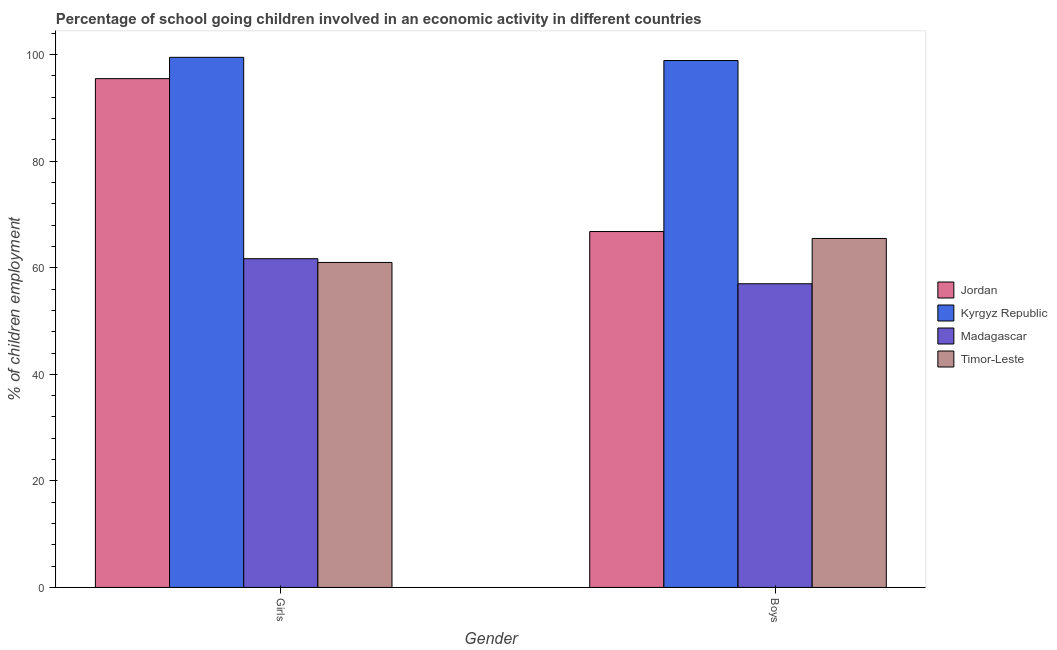What is the label of the 1st group of bars from the left?
Ensure brevity in your answer.  Girls. What is the percentage of school going girls in Timor-Leste?
Your answer should be compact. 61. Across all countries, what is the maximum percentage of school going girls?
Offer a terse response. 99.5. In which country was the percentage of school going girls maximum?
Your answer should be very brief. Kyrgyz Republic. In which country was the percentage of school going girls minimum?
Keep it short and to the point. Timor-Leste. What is the total percentage of school going boys in the graph?
Your answer should be compact. 288.2. What is the difference between the percentage of school going boys in Jordan and that in Kyrgyz Republic?
Give a very brief answer. -32.1. What is the difference between the percentage of school going boys in Madagascar and the percentage of school going girls in Kyrgyz Republic?
Your response must be concise. -42.5. What is the average percentage of school going girls per country?
Ensure brevity in your answer.  79.42. What is the difference between the percentage of school going boys and percentage of school going girls in Kyrgyz Republic?
Provide a short and direct response. -0.6. What is the ratio of the percentage of school going boys in Timor-Leste to that in Kyrgyz Republic?
Keep it short and to the point. 0.66. Is the percentage of school going boys in Timor-Leste less than that in Madagascar?
Offer a terse response. No. In how many countries, is the percentage of school going girls greater than the average percentage of school going girls taken over all countries?
Offer a terse response. 2. What does the 2nd bar from the left in Boys represents?
Keep it short and to the point. Kyrgyz Republic. What does the 1st bar from the right in Boys represents?
Ensure brevity in your answer.  Timor-Leste. Are all the bars in the graph horizontal?
Provide a short and direct response. No. Are the values on the major ticks of Y-axis written in scientific E-notation?
Keep it short and to the point. No. Does the graph contain any zero values?
Your answer should be very brief. No. Does the graph contain grids?
Make the answer very short. No. How are the legend labels stacked?
Offer a very short reply. Vertical. What is the title of the graph?
Make the answer very short. Percentage of school going children involved in an economic activity in different countries. Does "Cyprus" appear as one of the legend labels in the graph?
Provide a short and direct response. No. What is the label or title of the X-axis?
Make the answer very short. Gender. What is the label or title of the Y-axis?
Your response must be concise. % of children employment. What is the % of children employment in Jordan in Girls?
Make the answer very short. 95.5. What is the % of children employment in Kyrgyz Republic in Girls?
Keep it short and to the point. 99.5. What is the % of children employment in Madagascar in Girls?
Make the answer very short. 61.7. What is the % of children employment of Jordan in Boys?
Make the answer very short. 66.8. What is the % of children employment of Kyrgyz Republic in Boys?
Your answer should be very brief. 98.9. What is the % of children employment of Madagascar in Boys?
Keep it short and to the point. 57. What is the % of children employment of Timor-Leste in Boys?
Provide a short and direct response. 65.5. Across all Gender, what is the maximum % of children employment of Jordan?
Provide a succinct answer. 95.5. Across all Gender, what is the maximum % of children employment in Kyrgyz Republic?
Provide a succinct answer. 99.5. Across all Gender, what is the maximum % of children employment in Madagascar?
Ensure brevity in your answer.  61.7. Across all Gender, what is the maximum % of children employment in Timor-Leste?
Provide a succinct answer. 65.5. Across all Gender, what is the minimum % of children employment of Jordan?
Provide a short and direct response. 66.8. Across all Gender, what is the minimum % of children employment in Kyrgyz Republic?
Your answer should be very brief. 98.9. Across all Gender, what is the minimum % of children employment in Madagascar?
Provide a succinct answer. 57. What is the total % of children employment of Jordan in the graph?
Your response must be concise. 162.3. What is the total % of children employment of Kyrgyz Republic in the graph?
Offer a terse response. 198.4. What is the total % of children employment of Madagascar in the graph?
Provide a short and direct response. 118.7. What is the total % of children employment in Timor-Leste in the graph?
Make the answer very short. 126.5. What is the difference between the % of children employment of Jordan in Girls and that in Boys?
Your answer should be compact. 28.7. What is the difference between the % of children employment of Kyrgyz Republic in Girls and that in Boys?
Your response must be concise. 0.6. What is the difference between the % of children employment in Timor-Leste in Girls and that in Boys?
Your answer should be compact. -4.5. What is the difference between the % of children employment in Jordan in Girls and the % of children employment in Kyrgyz Republic in Boys?
Provide a succinct answer. -3.4. What is the difference between the % of children employment in Jordan in Girls and the % of children employment in Madagascar in Boys?
Your response must be concise. 38.5. What is the difference between the % of children employment of Jordan in Girls and the % of children employment of Timor-Leste in Boys?
Provide a succinct answer. 30. What is the difference between the % of children employment of Kyrgyz Republic in Girls and the % of children employment of Madagascar in Boys?
Ensure brevity in your answer.  42.5. What is the average % of children employment of Jordan per Gender?
Keep it short and to the point. 81.15. What is the average % of children employment of Kyrgyz Republic per Gender?
Offer a very short reply. 99.2. What is the average % of children employment of Madagascar per Gender?
Keep it short and to the point. 59.35. What is the average % of children employment of Timor-Leste per Gender?
Provide a short and direct response. 63.25. What is the difference between the % of children employment of Jordan and % of children employment of Kyrgyz Republic in Girls?
Make the answer very short. -4. What is the difference between the % of children employment in Jordan and % of children employment in Madagascar in Girls?
Provide a succinct answer. 33.8. What is the difference between the % of children employment in Jordan and % of children employment in Timor-Leste in Girls?
Make the answer very short. 34.5. What is the difference between the % of children employment in Kyrgyz Republic and % of children employment in Madagascar in Girls?
Keep it short and to the point. 37.8. What is the difference between the % of children employment of Kyrgyz Republic and % of children employment of Timor-Leste in Girls?
Offer a very short reply. 38.5. What is the difference between the % of children employment in Jordan and % of children employment in Kyrgyz Republic in Boys?
Offer a terse response. -32.1. What is the difference between the % of children employment in Jordan and % of children employment in Timor-Leste in Boys?
Provide a short and direct response. 1.3. What is the difference between the % of children employment in Kyrgyz Republic and % of children employment in Madagascar in Boys?
Give a very brief answer. 41.9. What is the difference between the % of children employment of Kyrgyz Republic and % of children employment of Timor-Leste in Boys?
Offer a terse response. 33.4. What is the ratio of the % of children employment of Jordan in Girls to that in Boys?
Offer a terse response. 1.43. What is the ratio of the % of children employment of Madagascar in Girls to that in Boys?
Your answer should be compact. 1.08. What is the ratio of the % of children employment in Timor-Leste in Girls to that in Boys?
Your answer should be compact. 0.93. What is the difference between the highest and the second highest % of children employment of Jordan?
Offer a terse response. 28.7. What is the difference between the highest and the lowest % of children employment in Jordan?
Give a very brief answer. 28.7. 